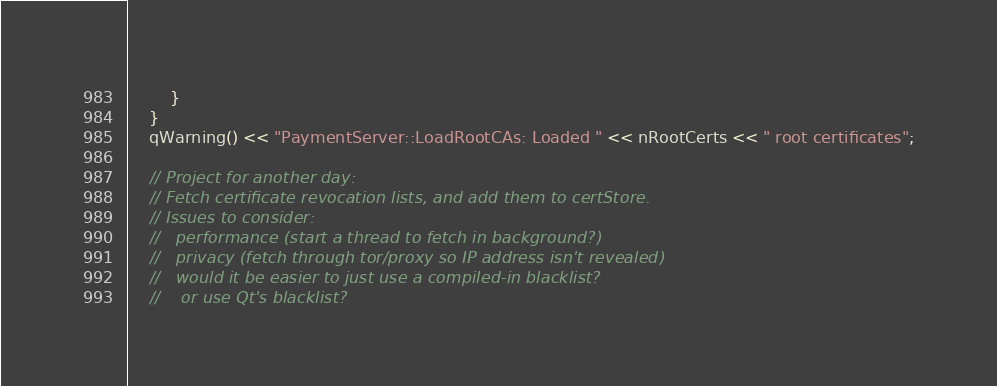<code> <loc_0><loc_0><loc_500><loc_500><_C++_>        }
    }
    qWarning() << "PaymentServer::LoadRootCAs: Loaded " << nRootCerts << " root certificates";

    // Project for another day:
    // Fetch certificate revocation lists, and add them to certStore.
    // Issues to consider:
    //   performance (start a thread to fetch in background?)
    //   privacy (fetch through tor/proxy so IP address isn't revealed)
    //   would it be easier to just use a compiled-in blacklist?
    //    or use Qt's blacklist?</code> 